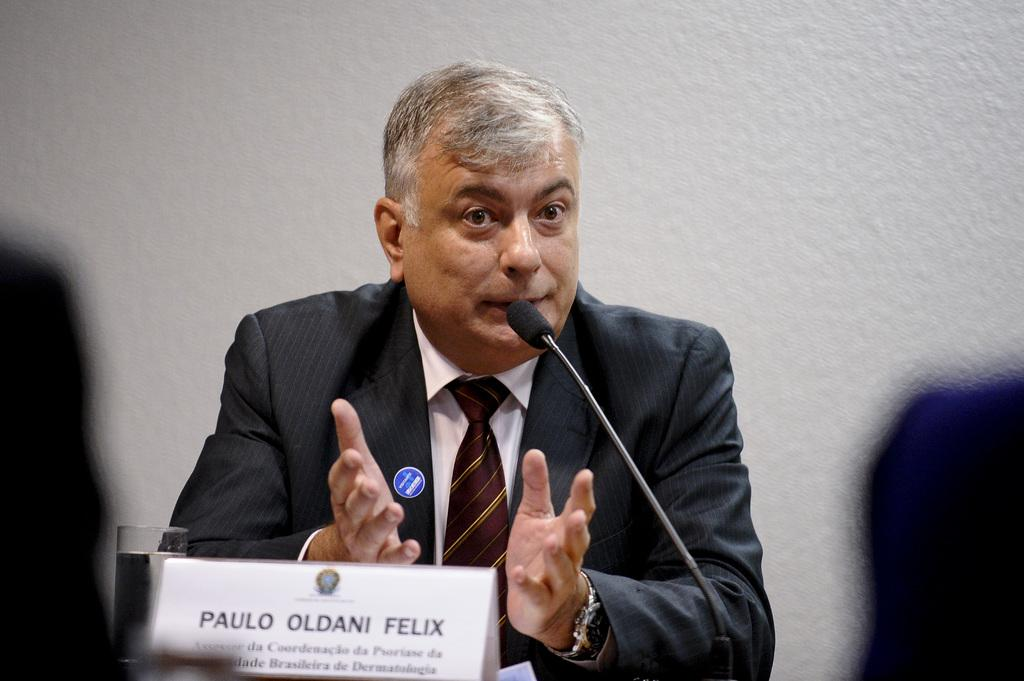What is the main subject of the image? There is a person in the image. What type of clothing is the person wearing? The person is wearing a blazer and a tie. What object can be seen in the image that might be used for identification? There is a name board in the image. What object is in front of the person? There is a glass in front of the person. What object is in the middle of the image that might be used for speaking? There is a microphone (mic) in the middle of the image. Can you see a kitty playing with a quartz crystal on the name board in the image? No, there is no kitty or quartz crystal present in the image. 